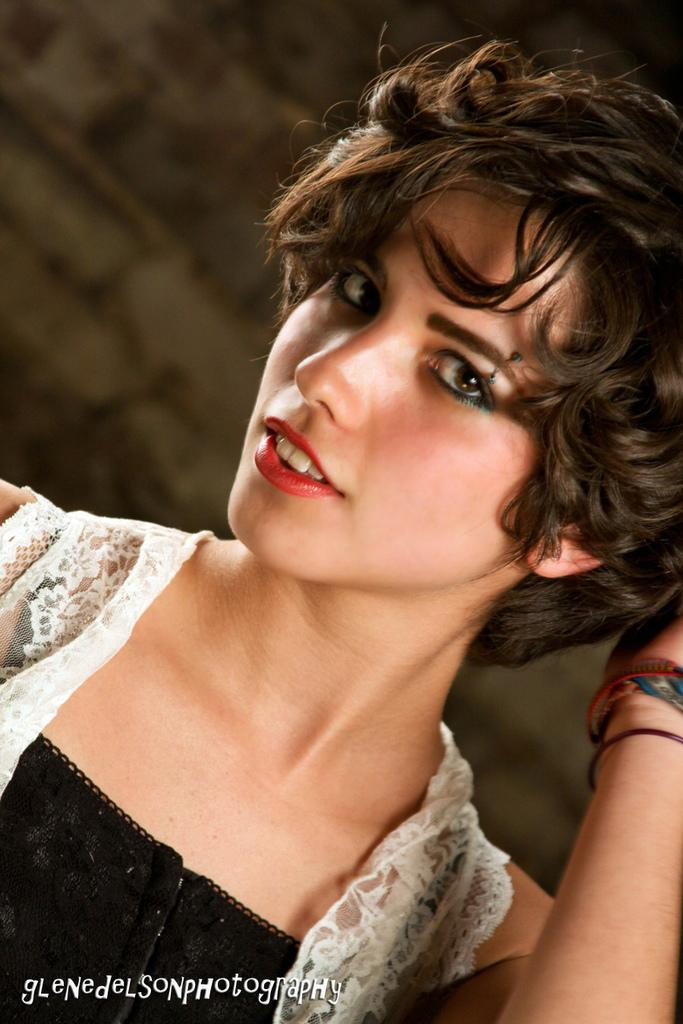What is the main subject of the image? The main subject of the image is a woman. Can you describe any additional details about the woman? Unfortunately, the provided facts do not offer any additional details about the woman. What is written at the bottom of the image? There is text at the bottom of the image. Is the woman playing a guitar in the image? There is no mention of a guitar or any musical instrument in the image. What is the topic of the discussion between the woman and another person in the image? There is no discussion or other person present in the image. 